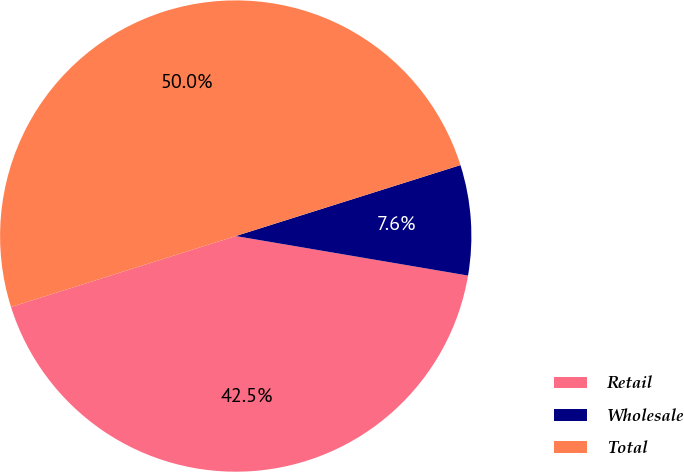<chart> <loc_0><loc_0><loc_500><loc_500><pie_chart><fcel>Retail<fcel>Wholesale<fcel>Total<nl><fcel>42.45%<fcel>7.55%<fcel>50.0%<nl></chart> 